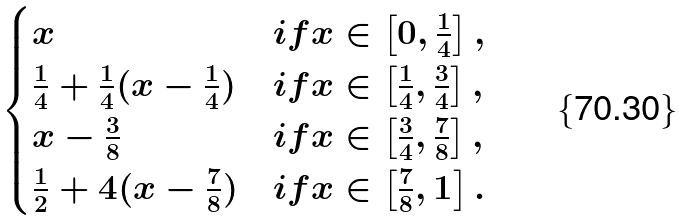<formula> <loc_0><loc_0><loc_500><loc_500>\begin{cases} x & i f x \in \left [ 0 , \frac { 1 } { 4 } \right ] , \\ \frac { 1 } { 4 } + \frac { 1 } { 4 } ( x - \frac { 1 } { 4 } ) & i f x \in \left [ \frac { 1 } { 4 } , \frac { 3 } { 4 } \right ] , \\ x - \frac { 3 } { 8 } & i f x \in \left [ \frac { 3 } { 4 } , \frac { 7 } { 8 } \right ] , \\ \frac { 1 } { 2 } + 4 ( x - \frac { 7 } { 8 } ) & i f x \in \left [ \frac { 7 } { 8 } , 1 \right ] . \end{cases}</formula> 